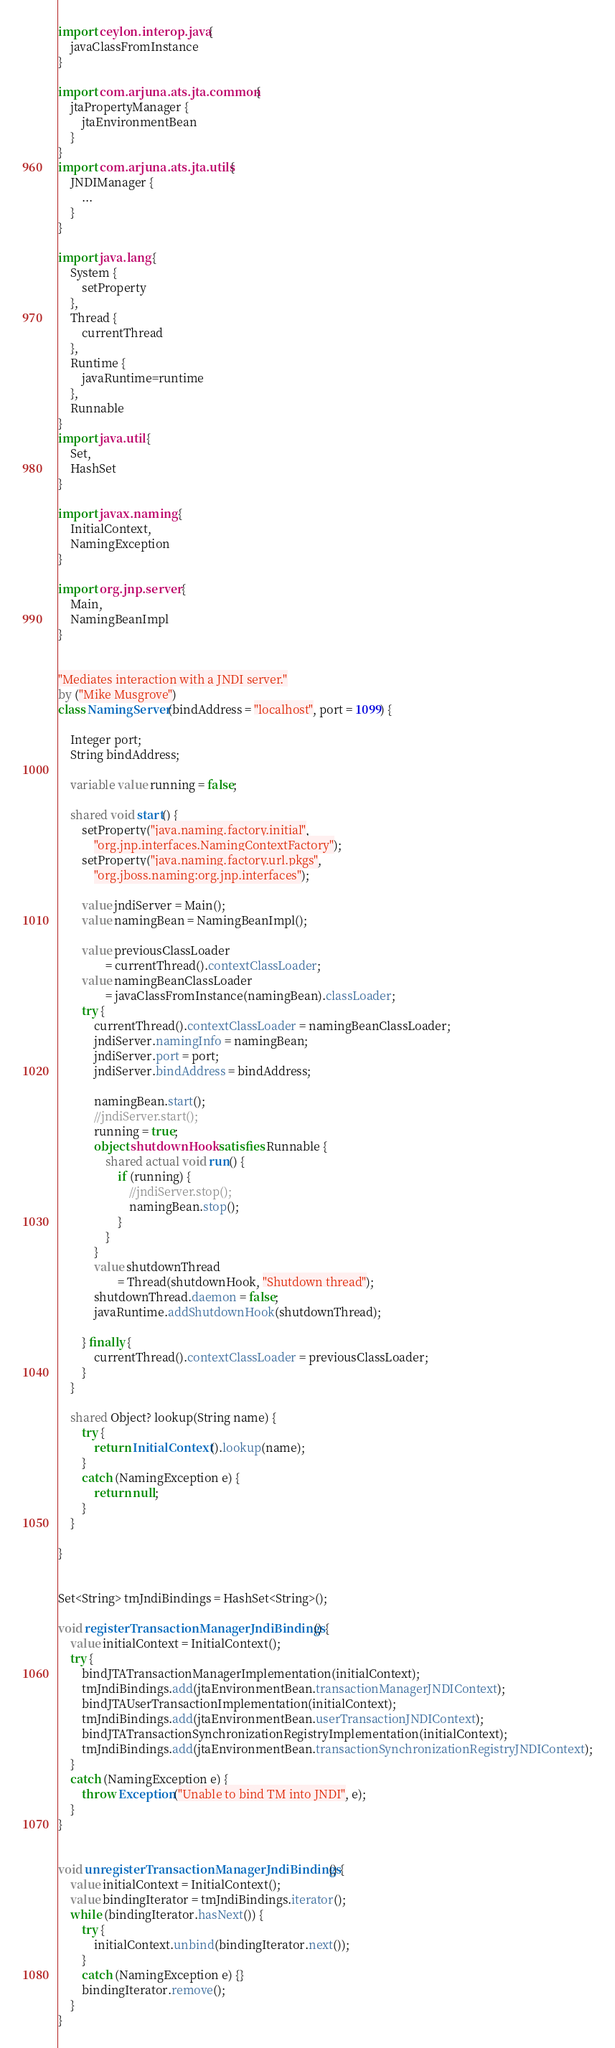<code> <loc_0><loc_0><loc_500><loc_500><_Ceylon_>import ceylon.interop.java {
    javaClassFromInstance
}

import com.arjuna.ats.jta.common {
    jtaPropertyManager {
        jtaEnvironmentBean
    }
}
import com.arjuna.ats.jta.utils {
    JNDIManager {
        ...
    }
}

import java.lang {
    System {
        setProperty
    },
    Thread {
        currentThread
    },
    Runtime {
        javaRuntime=runtime
    },
    Runnable
}
import java.util {
    Set,
    HashSet
}

import javax.naming {
    InitialContext,
    NamingException
}

import org.jnp.server {
    Main,
    NamingBeanImpl
}


"Mediates interaction with a JNDI server."
by ("Mike Musgrove")
class NamingServer(bindAddress = "localhost", port = 1099) {
    
    Integer port;
    String bindAddress;
    
    variable value running = false;
    
    shared void start() {
        setProperty("java.naming.factory.initial", 
            "org.jnp.interfaces.NamingContextFactory");
        setProperty("java.naming.factory.url.pkgs", 
            "org.jboss.naming:org.jnp.interfaces");
        
        value jndiServer = Main();
        value namingBean = NamingBeanImpl();
        
        value previousClassLoader 
                = currentThread().contextClassLoader;
        value namingBeanClassLoader 
                = javaClassFromInstance(namingBean).classLoader;
        try {
            currentThread().contextClassLoader = namingBeanClassLoader;
            jndiServer.namingInfo = namingBean;
            jndiServer.port = port;
            jndiServer.bindAddress = bindAddress;

            namingBean.start();
            //jndiServer.start();
            running = true;
            object shutdownHook satisfies Runnable {
                shared actual void run() {
                    if (running) {
                        //jndiServer.stop();
                        namingBean.stop();
                    }
                }
            }
            value shutdownThread 
                    = Thread(shutdownHook, "Shutdown thread");
            shutdownThread.daemon = false;
            javaRuntime.addShutdownHook(shutdownThread);

        } finally {
            currentThread().contextClassLoader = previousClassLoader;
        }
    }

    shared Object? lookup(String name) {
        try {
            return InitialContext().lookup(name);
        }
        catch (NamingException e) {
            return null;
        }
    }
    
}


Set<String> tmJndiBindings = HashSet<String>();

void registerTransactionManagerJndiBindings() {
    value initialContext = InitialContext();
    try {
        bindJTATransactionManagerImplementation(initialContext);
        tmJndiBindings.add(jtaEnvironmentBean.transactionManagerJNDIContext);
        bindJTAUserTransactionImplementation(initialContext);
        tmJndiBindings.add(jtaEnvironmentBean.userTransactionJNDIContext);
        bindJTATransactionSynchronizationRegistryImplementation(initialContext);
        tmJndiBindings.add(jtaEnvironmentBean.transactionSynchronizationRegistryJNDIContext);
    }
    catch (NamingException e) {
        throw Exception("Unable to bind TM into JNDI", e);
    }
}


void unregisterTransactionManagerJndiBindings() {
    value initialContext = InitialContext();
    value bindingIterator = tmJndiBindings.iterator();
    while (bindingIterator.hasNext()) {
        try {
            initialContext.unbind(bindingIterator.next());
        }
        catch (NamingException e) {}
        bindingIterator.remove();
    }
}

</code> 